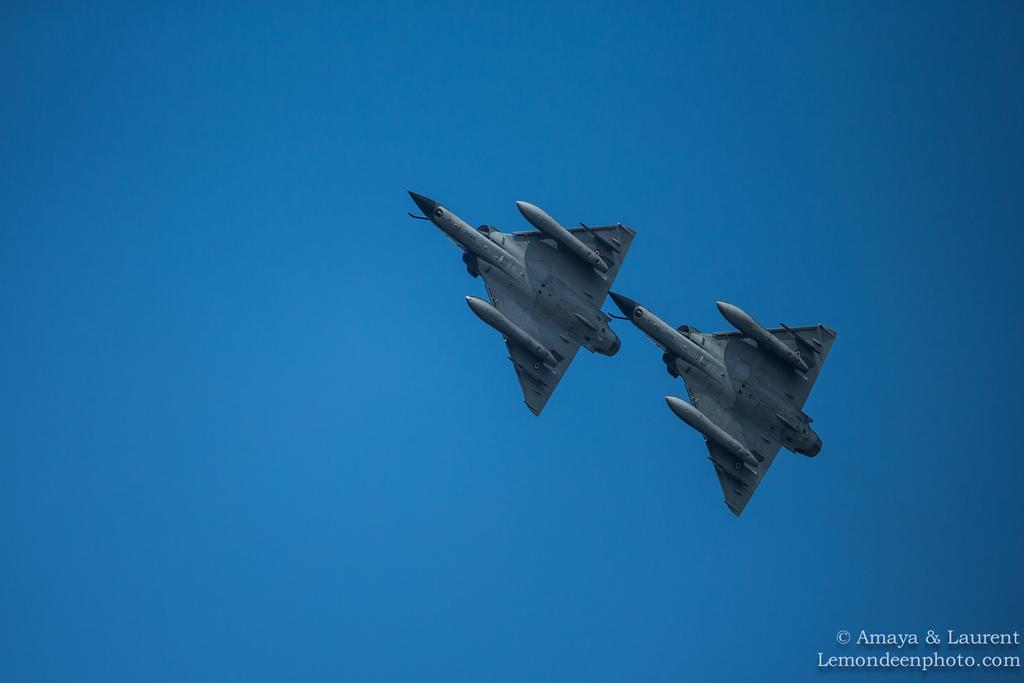What website does this have listed for the photographer?
Your answer should be very brief. Lemondeenphoto.com. What are the names of the photographers?
Your answer should be very brief. Amaya & laurent. 